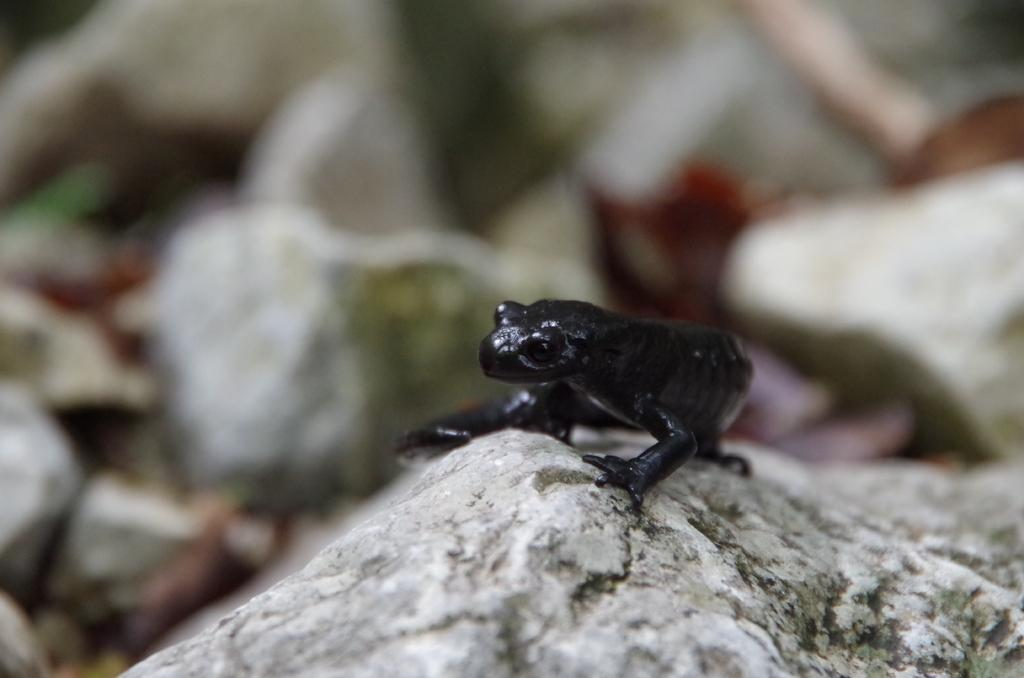What is at the bottom of the image? There are stones at the bottom of the image. Is there any living creature on the stones? Yes, there is a frog on one of the stones. Can you describe the background of the image? The background of the image is blurred. What type of silk fabric is draped over the woman in the image? There is no woman or silk fabric present in the image; it features stones and a frog. 